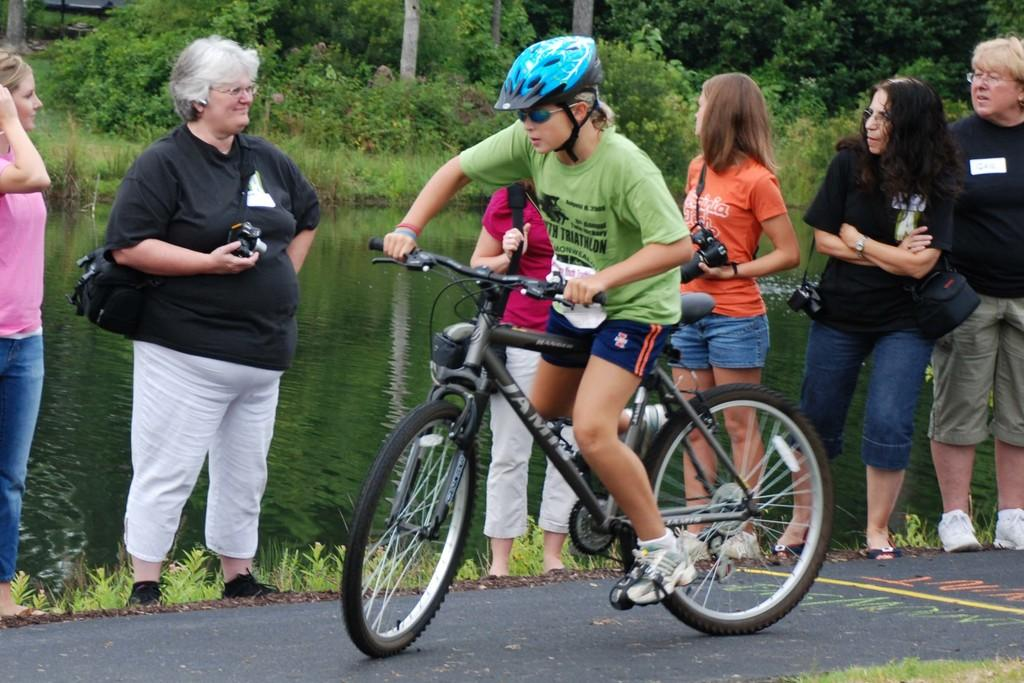What is the person in the image doing? The person is riding a bicycle in the image. What is the person wearing while riding the bicycle? The person is wearing a green dress. Where is the bicycle located? The bicycle is on a road in the image. Can you describe the surroundings in the image? There is a group of people, trees, and a river visible in the image. What is the person's elbow doing in the image? There is no mention of the person's elbow in the image, so it cannot be determined what it is doing. 